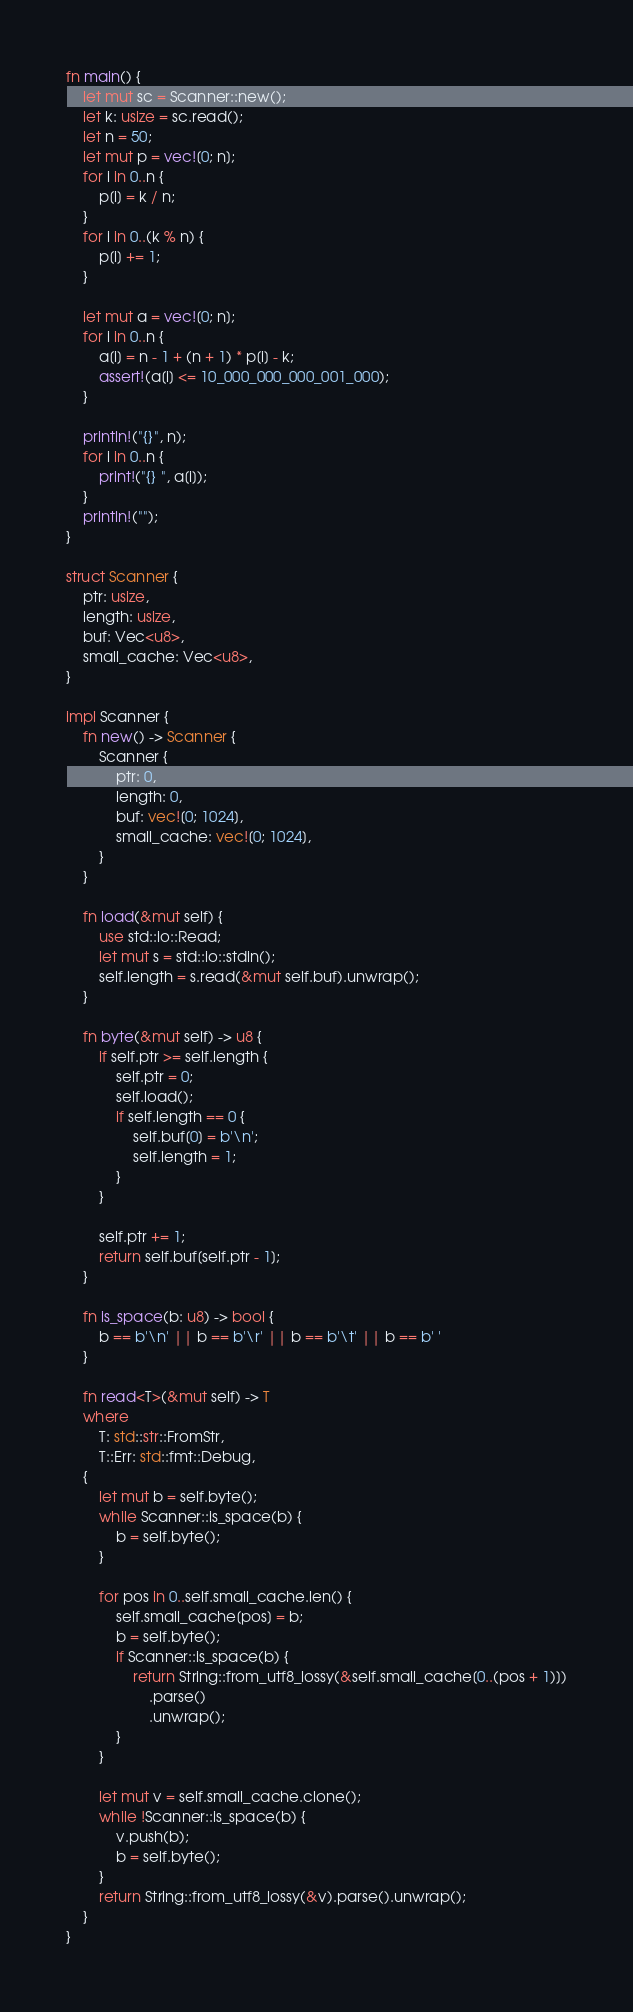<code> <loc_0><loc_0><loc_500><loc_500><_Rust_>fn main() {
    let mut sc = Scanner::new();
    let k: usize = sc.read();
    let n = 50;
    let mut p = vec![0; n];
    for i in 0..n {
        p[i] = k / n;
    }
    for i in 0..(k % n) {
        p[i] += 1;
    }

    let mut a = vec![0; n];
    for i in 0..n {
        a[i] = n - 1 + (n + 1) * p[i] - k;
        assert!(a[i] <= 10_000_000_000_001_000);
    }

    println!("{}", n);
    for i in 0..n {
        print!("{} ", a[i]);
    }
    println!("");
}

struct Scanner {
    ptr: usize,
    length: usize,
    buf: Vec<u8>,
    small_cache: Vec<u8>,
}

impl Scanner {
    fn new() -> Scanner {
        Scanner {
            ptr: 0,
            length: 0,
            buf: vec![0; 1024],
            small_cache: vec![0; 1024],
        }
    }

    fn load(&mut self) {
        use std::io::Read;
        let mut s = std::io::stdin();
        self.length = s.read(&mut self.buf).unwrap();
    }

    fn byte(&mut self) -> u8 {
        if self.ptr >= self.length {
            self.ptr = 0;
            self.load();
            if self.length == 0 {
                self.buf[0] = b'\n';
                self.length = 1;
            }
        }

        self.ptr += 1;
        return self.buf[self.ptr - 1];
    }

    fn is_space(b: u8) -> bool {
        b == b'\n' || b == b'\r' || b == b'\t' || b == b' '
    }

    fn read<T>(&mut self) -> T
    where
        T: std::str::FromStr,
        T::Err: std::fmt::Debug,
    {
        let mut b = self.byte();
        while Scanner::is_space(b) {
            b = self.byte();
        }

        for pos in 0..self.small_cache.len() {
            self.small_cache[pos] = b;
            b = self.byte();
            if Scanner::is_space(b) {
                return String::from_utf8_lossy(&self.small_cache[0..(pos + 1)])
                    .parse()
                    .unwrap();
            }
        }

        let mut v = self.small_cache.clone();
        while !Scanner::is_space(b) {
            v.push(b);
            b = self.byte();
        }
        return String::from_utf8_lossy(&v).parse().unwrap();
    }
}
</code> 